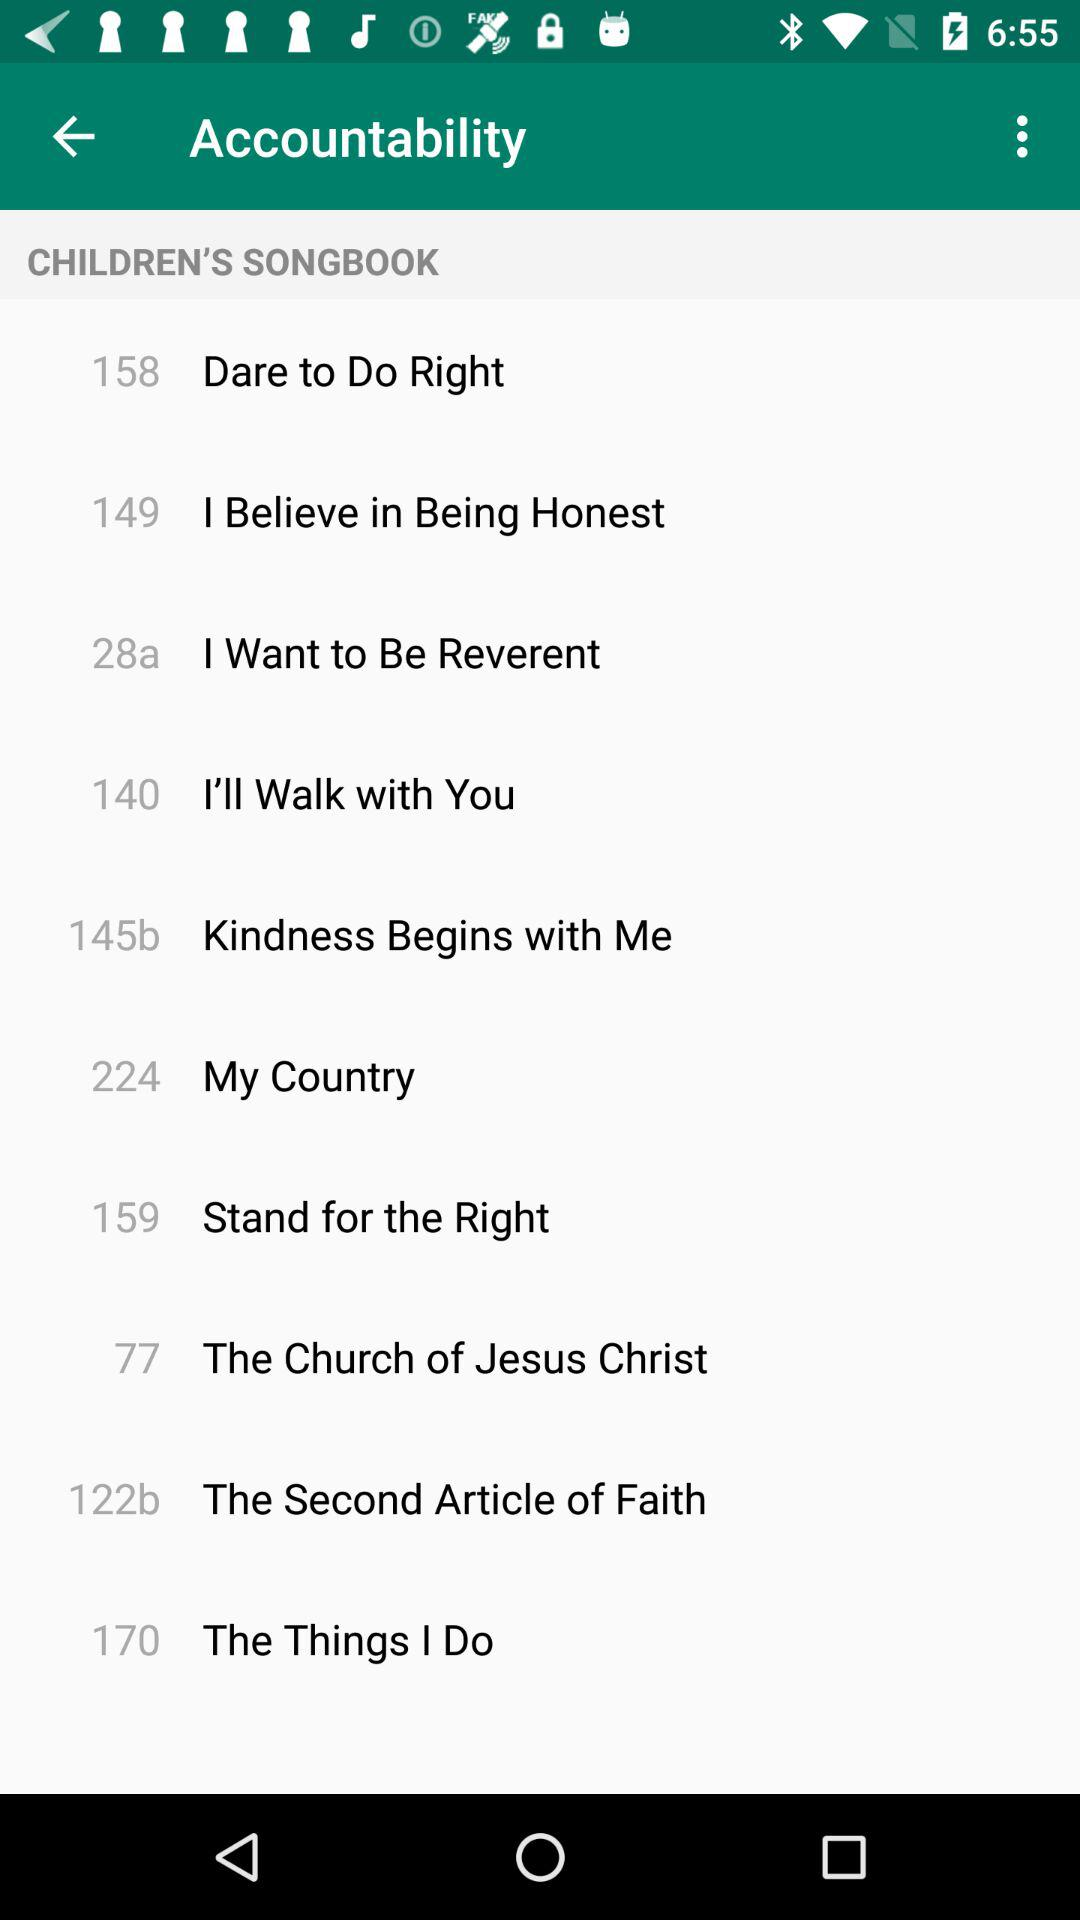Which song is on page number 149? The song on page number 149 is "I Believe in Being Honest". 